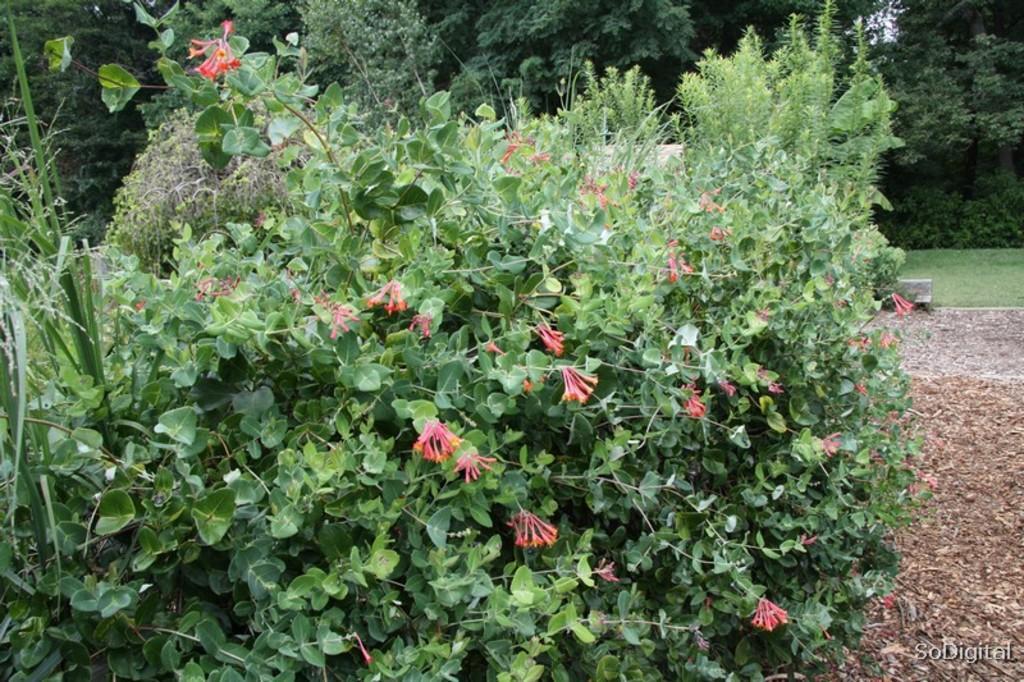Please provide a concise description of this image. A picture of a garden. Front there are plants with flowers. Far there are number of trees. Grass is in green color. 